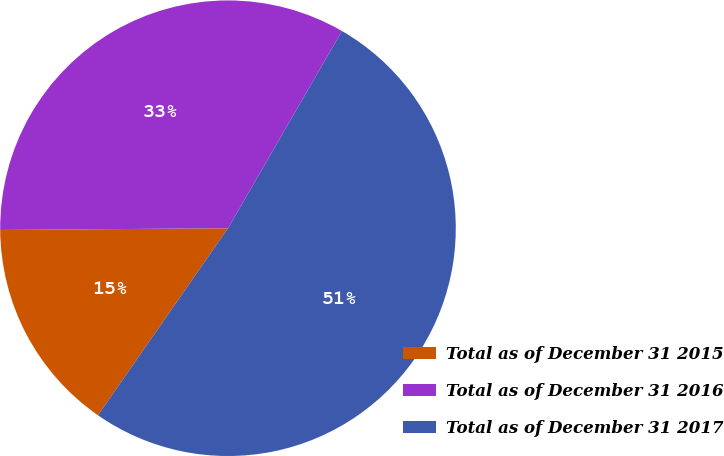<chart> <loc_0><loc_0><loc_500><loc_500><pie_chart><fcel>Total as of December 31 2015<fcel>Total as of December 31 2016<fcel>Total as of December 31 2017<nl><fcel>15.21%<fcel>33.46%<fcel>51.33%<nl></chart> 